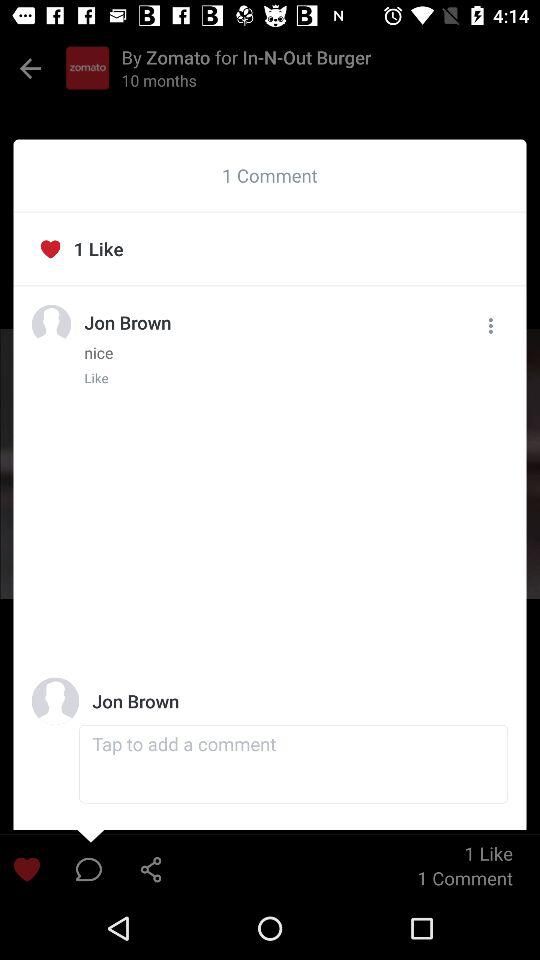How many comments are there? There is 1 comment. 